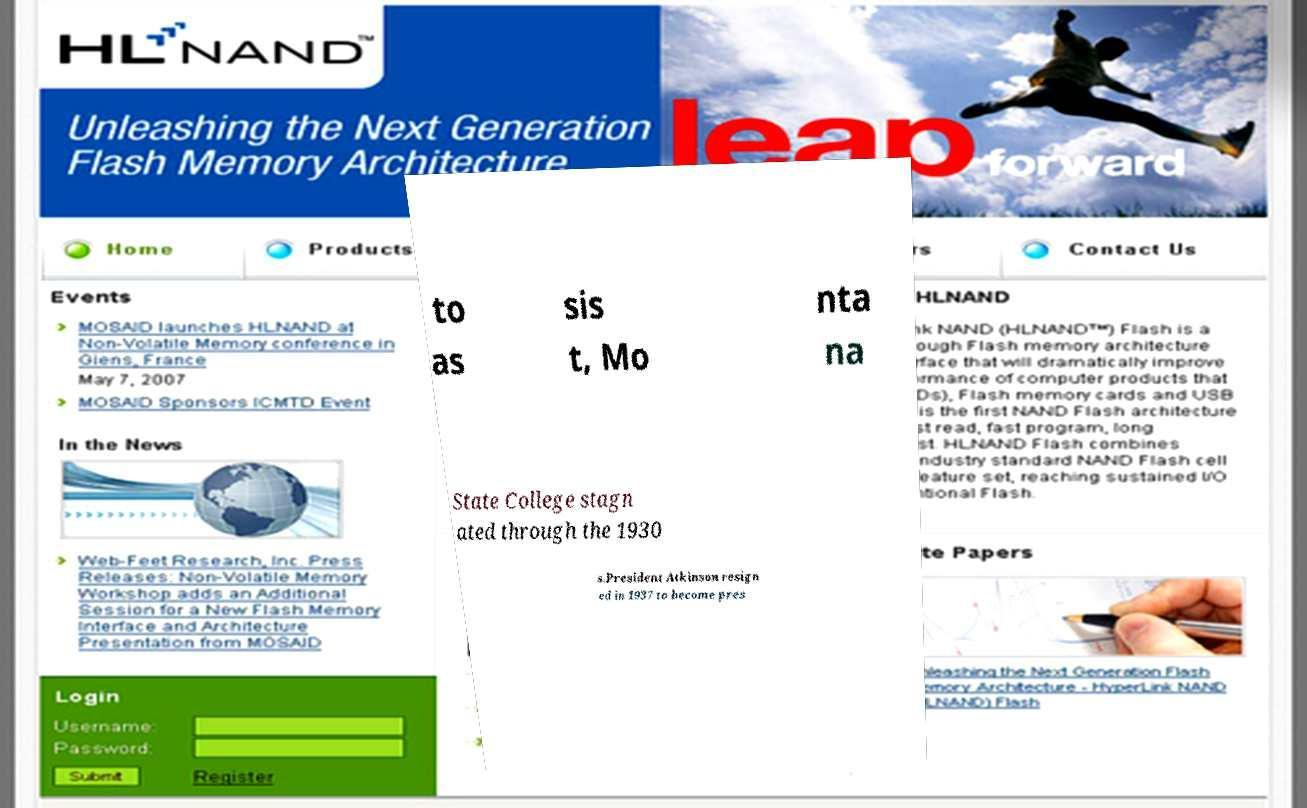Could you assist in decoding the text presented in this image and type it out clearly? to as sis t, Mo nta na State College stagn ated through the 1930 s.President Atkinson resign ed in 1937 to become pres 